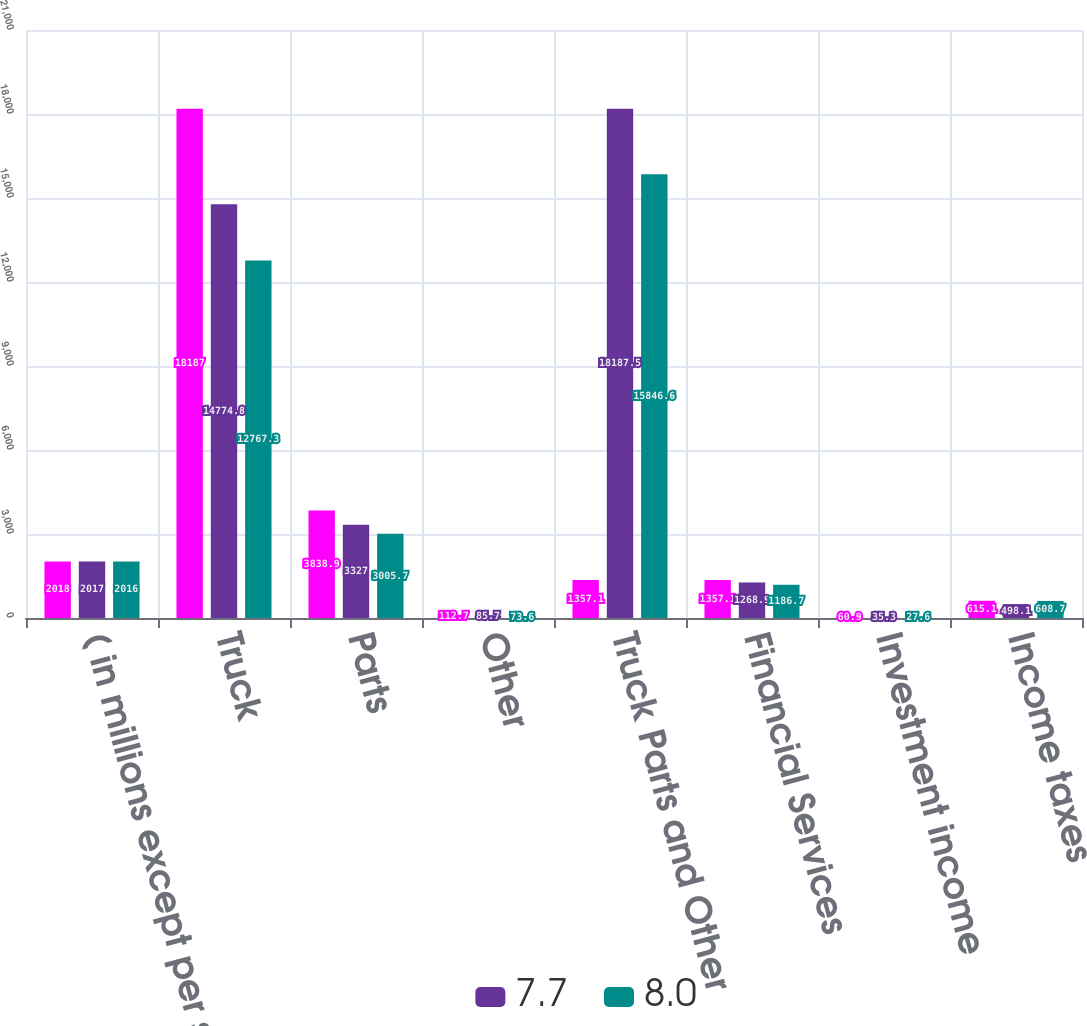<chart> <loc_0><loc_0><loc_500><loc_500><stacked_bar_chart><ecel><fcel>( in millions except per share<fcel>Truck<fcel>Parts<fcel>Other<fcel>Truck Parts and Other<fcel>Financial Services<fcel>Investment income<fcel>Income taxes<nl><fcel>nan<fcel>2018<fcel>18187<fcel>3838.9<fcel>112.7<fcel>1357.1<fcel>1357.1<fcel>60.9<fcel>615.1<nl><fcel>7.7<fcel>2017<fcel>14774.8<fcel>3327<fcel>85.7<fcel>18187.5<fcel>1268.9<fcel>35.3<fcel>498.1<nl><fcel>8<fcel>2016<fcel>12767.3<fcel>3005.7<fcel>73.6<fcel>15846.6<fcel>1186.7<fcel>27.6<fcel>608.7<nl></chart> 